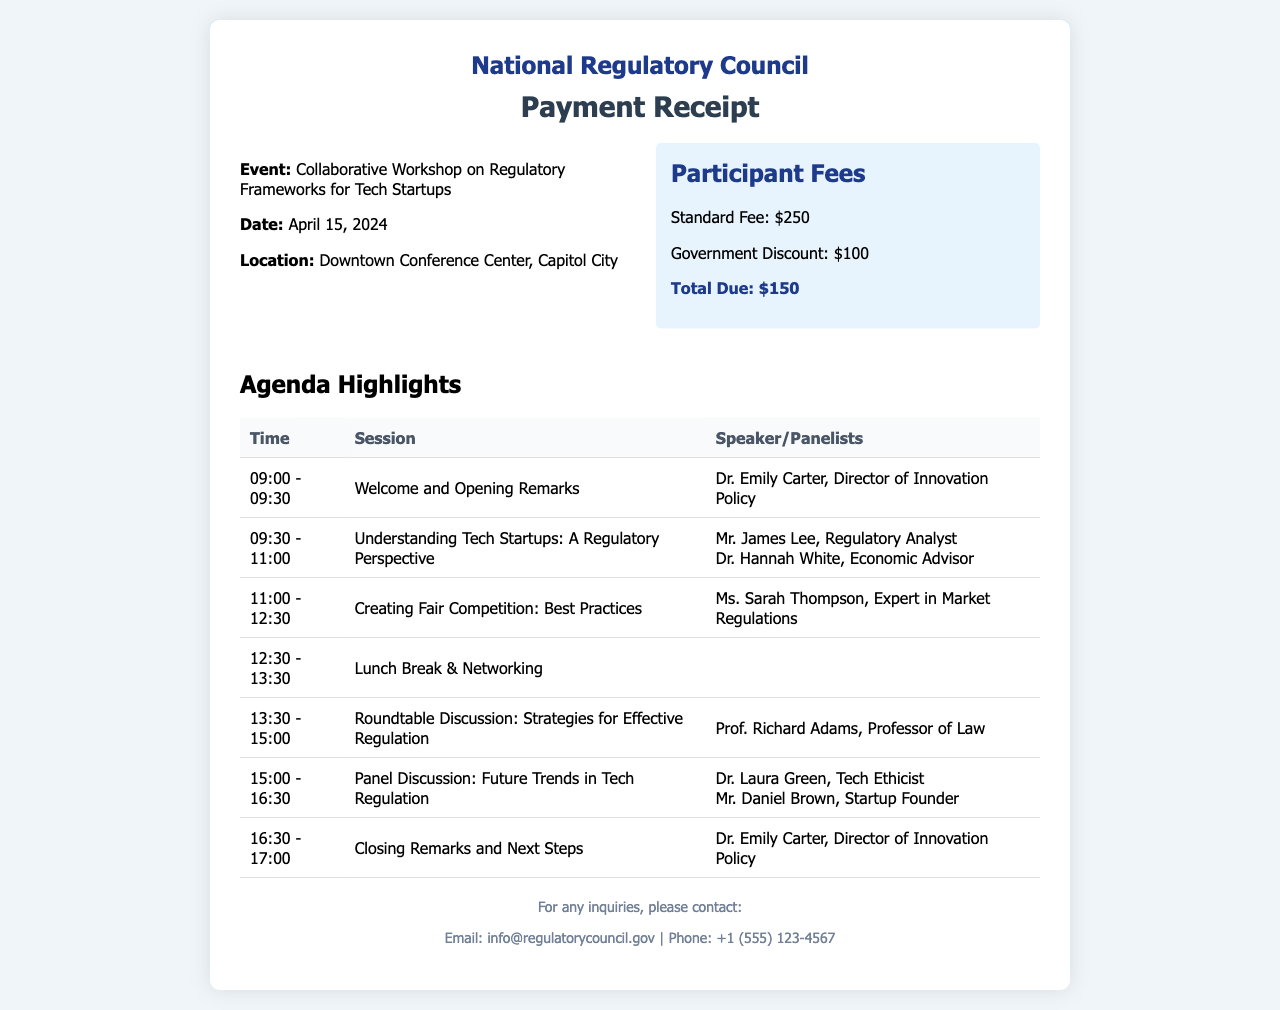what is the event title? The event title is explicitly stated in the document, which is "Collaborative Workshop on Regulatory Frameworks for Tech Startups."
Answer: Collaborative Workshop on Regulatory Frameworks for Tech Startups what is the total due amount? The total due amount is highlighted in the fees section as $150.
Answer: $150 who is the speaker for "Understanding Tech Startups: A Regulatory Perspective"? The speakers for this session are mentioned in the agenda section, which lists Mr. James Lee and Dr. Hannah White.
Answer: Mr. James Lee, Dr. Hannah White when is the workshop scheduled? The workshop date is provided in the details section, stating "April 15, 2024."
Answer: April 15, 2024 what is the standard participant fee? The standard participant fee is specified in the fees section as $250.
Answer: $250 how long is the "Roundtable Discussion: Strategies for Effective Regulation"? The duration of the roundtable discussion is indicated in the agenda table as 1.5 hours.
Answer: 1.5 hours what is the location of the event? The location is explicitly stated in the details section as the "Downtown Conference Center, Capitol City."
Answer: Downtown Conference Center, Capitol City who will give the closing remarks? The document names Dr. Emily Carter as the speaker for the closing remarks session.
Answer: Dr. Emily Carter 